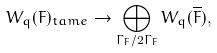<formula> <loc_0><loc_0><loc_500><loc_500>W _ { q } ( F ) _ { t a m e } \to \bigoplus _ { \Gamma _ { F } / 2 \Gamma _ { F } } W _ { q } ( \overline { F } ) ,</formula> 